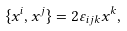Convert formula to latex. <formula><loc_0><loc_0><loc_500><loc_500>\{ x ^ { i } , x ^ { j } \} = 2 \varepsilon _ { i j k } x ^ { k } ,</formula> 